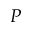Convert formula to latex. <formula><loc_0><loc_0><loc_500><loc_500>P</formula> 